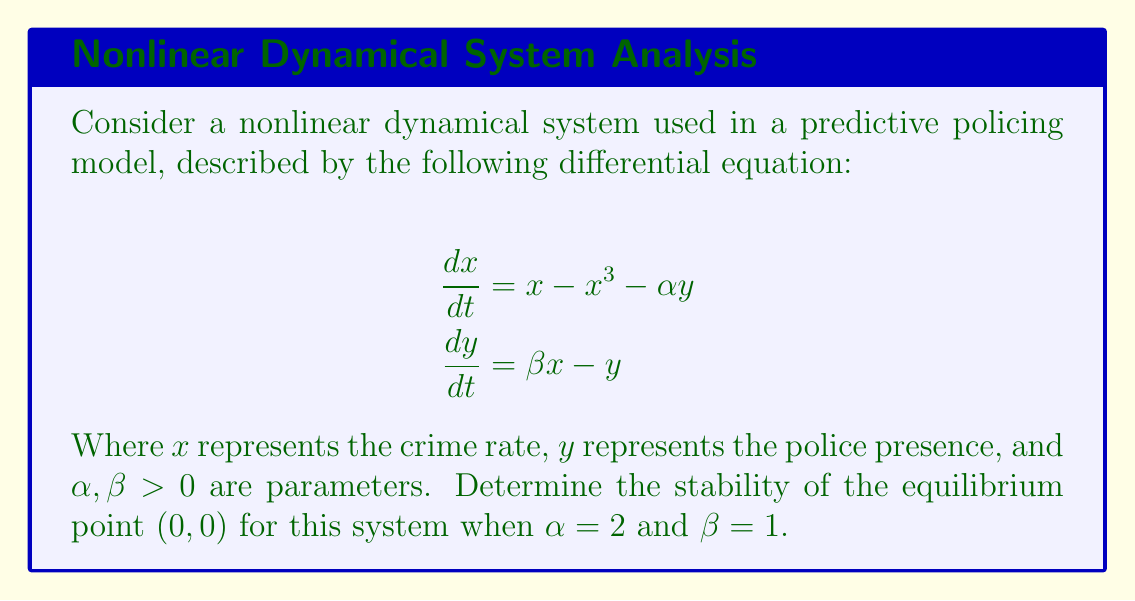Give your solution to this math problem. To determine the stability of the equilibrium point $(0,0)$, we need to follow these steps:

1. Find the Jacobian matrix of the system:
   $$J = \begin{bmatrix}
   \frac{\partial f_1}{\partial x} & \frac{\partial f_1}{\partial y} \\
   \frac{\partial f_2}{\partial x} & \frac{\partial f_2}{\partial y}
   \end{bmatrix}$$

   Where $f_1 = x - x^3 - \alpha y$ and $f_2 = \beta x - y$

2. Evaluate the Jacobian at the equilibrium point $(0,0)$:
   $$J_{(0,0)} = \begin{bmatrix}
   1 & -\alpha \\
   \beta & -1
   \end{bmatrix} = \begin{bmatrix}
   1 & -2 \\
   1 & -1
   \end{bmatrix}$$

3. Find the eigenvalues of $J_{(0,0)}$ by solving the characteristic equation:
   $$\det(J_{(0,0)} - \lambda I) = 0$$
   $$\begin{vmatrix}
   1-\lambda & -2 \\
   1 & -1-\lambda
   \end{vmatrix} = 0$$
   $$(1-\lambda)(-1-\lambda) - (-2)(1) = 0$$
   $$\lambda^2 - 2 = 0$$

4. Solve for $\lambda$:
   $$\lambda = \pm\sqrt{2}$$

5. Analyze the eigenvalues:
   Since we have one positive and one negative real eigenvalue, the equilibrium point $(0,0)$ is a saddle point.

6. Conclusion:
   The equilibrium point $(0,0)$ is unstable because one of the eigenvalues is positive.
Answer: Unstable saddle point 